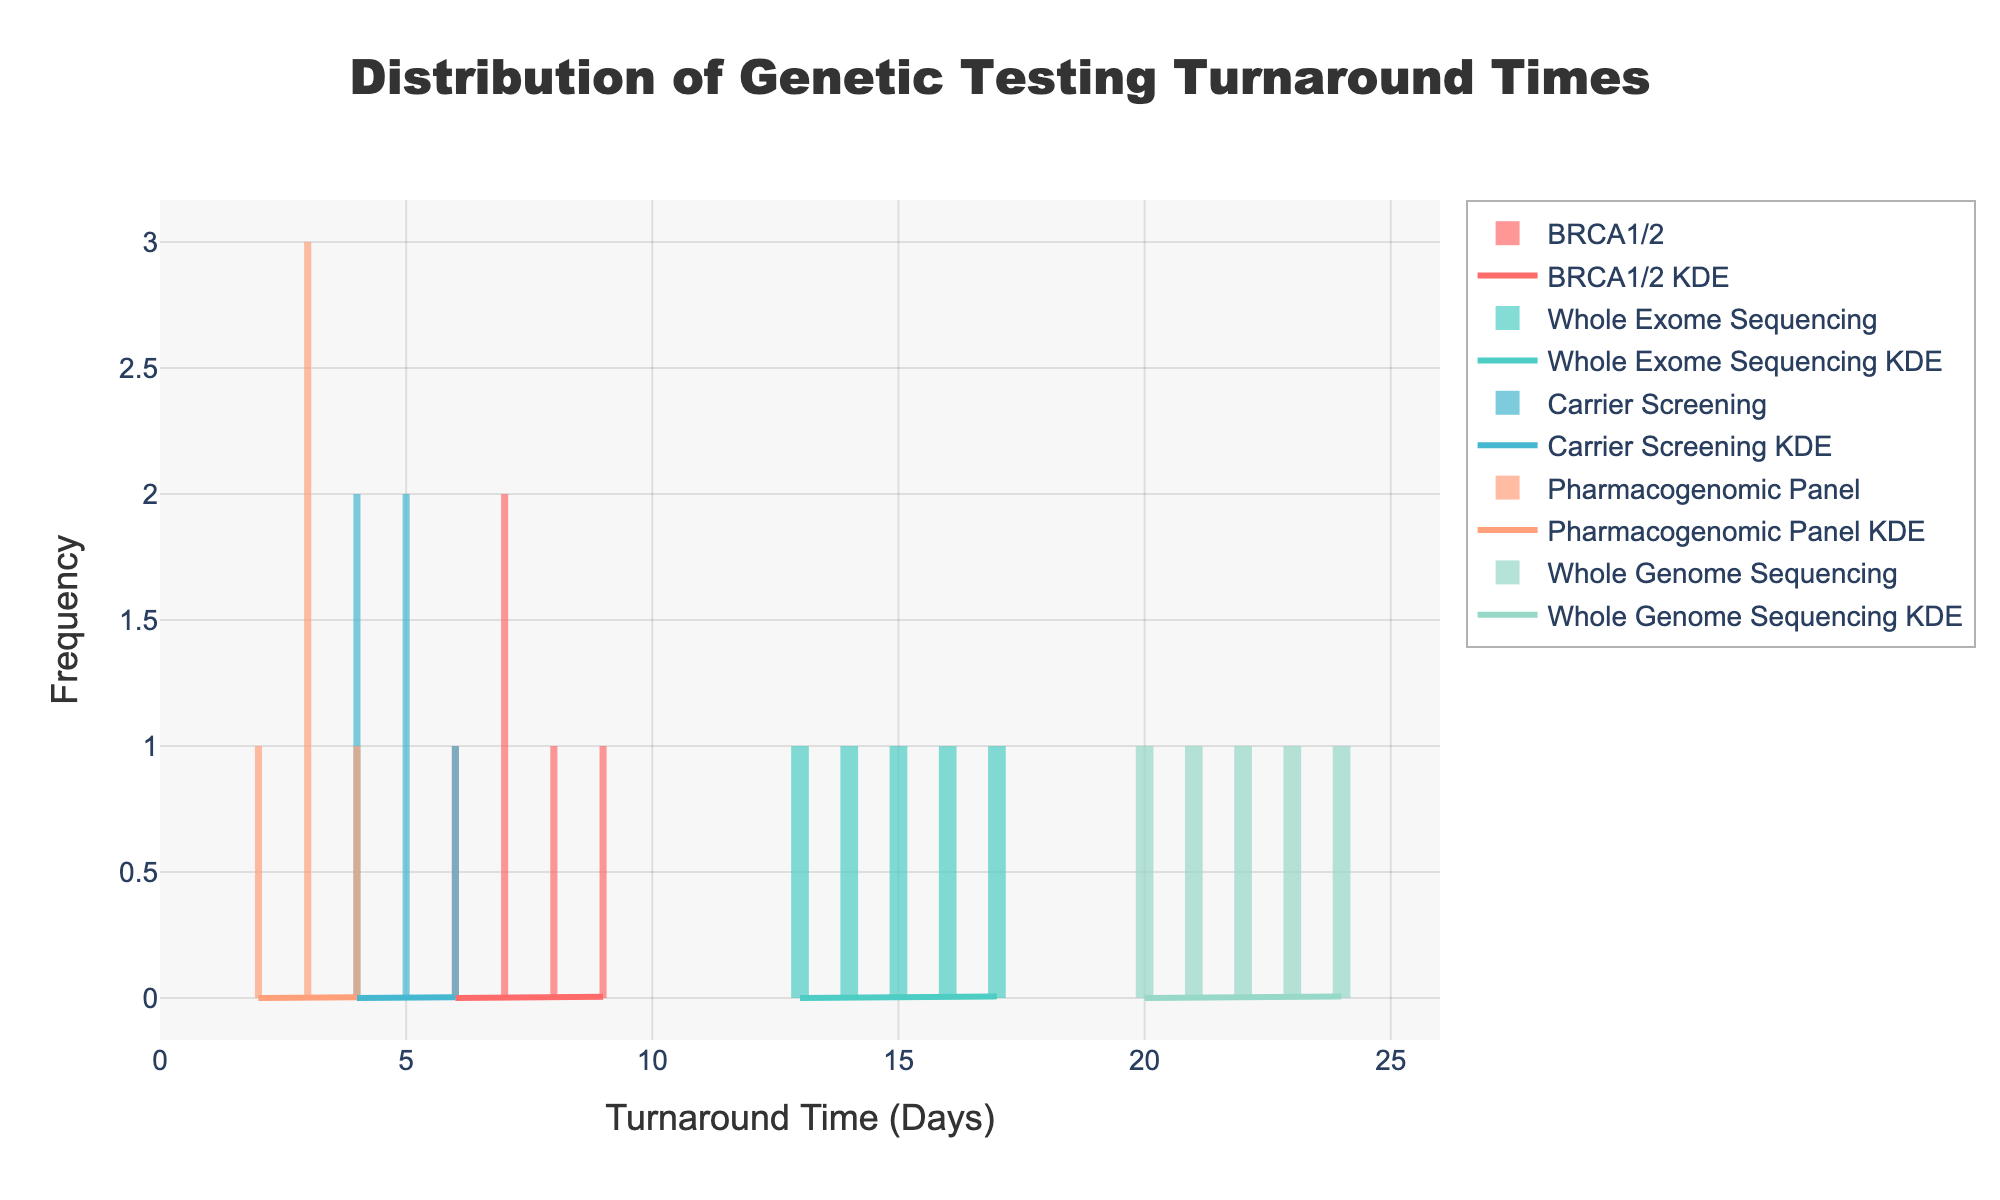What is the title of the figure? The title is displayed at the top of the figure. It reads "Distribution of Genetic Testing Turnaround Times".
Answer: Distribution of Genetic Testing Turnaround Times Which test type has the shortest turnaround time range? By looking at the histogram and KDE plots, the 'Pharmacogenomic Panel' has the shortest range, with turnaround times between 2 and 4 days.
Answer: Pharmacogenomic Panel Which test type has the highest peak in the histogram? Observing the histogram, 'Carrier Screening' has the highest peak with the highest frequency around 4-6 days.
Answer: Carrier Screening How does the peak of the KDE for 'Whole Exome Sequencing' compare to 'Whole Genome Sequencing'? The peak of the KDE for 'Whole Exome Sequencing' is lower and occurs at around 14-16 days, while 'Whole Genome Sequencing' has a higher peak around 22-24 days. This shows that turnaround times for Whole Genome Sequencing are generally longer.
Answer: Whole Genome Sequencing has a higher peak What are the x-axis and y-axis titles? The x-axis title is 'Turnaround Time (Days)', and the y-axis title is 'Frequency', as seen directly below and to the left of the axis respectively.
Answer: Turnaround Time (Days) and Frequency What is the average turnaround time for 'BRCA1/2' tests? The average can be calculated by summing up all the turnaround times and dividing by the number of data points: (7+8+6+9+7) / 5. This equals 37/5 = 7.4 days.
Answer: 7.4 days Which test type has the widest range of turnaround times? 'Whole Genome Sequencing' has turnaround times ranging from 20 to 24 days, the widest range compared to other test types.
Answer: Whole Genome Sequencing What color represents the 'Whole Exome Sequencing' tests in the histogram? 'Whole Exome Sequencing' is represented with a color that is bluish-green (#4ECDC4 in coding terms), distinguishable from other colors in the histogram.
Answer: Bluish-green How many peaks does the KDE for 'BRCA1/2' exhibit? The KDE for 'BRCA1/2' shows a single peak, indicating that the data is unimodal.
Answer: One peak Which test type’s KDE has the narrowest spread? 'Pharmacogenomic Panel' has a KDE with a narrow spread, indicating closely clustered data points around 2-4 days.
Answer: Pharmacogenomic Panel 